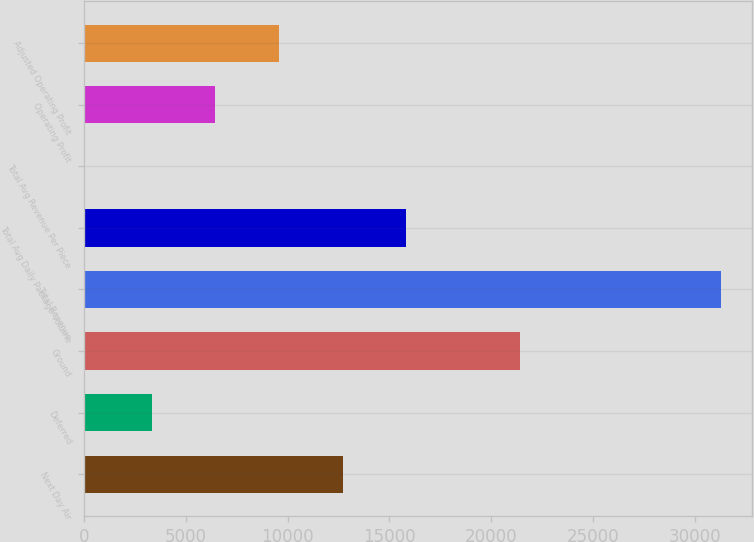Convert chart. <chart><loc_0><loc_0><loc_500><loc_500><bar_chart><fcel>Next Day Air<fcel>Deferred<fcel>Ground<fcel>Total Revenue<fcel>Total Avg Daily Package Volume<fcel>Total Avg Revenue Per Piece<fcel>Operating Profit<fcel>Adjusted Operating Profit<nl><fcel>12705.7<fcel>3325<fcel>21394<fcel>31278<fcel>15832.6<fcel>9.14<fcel>6451.89<fcel>9578.78<nl></chart> 